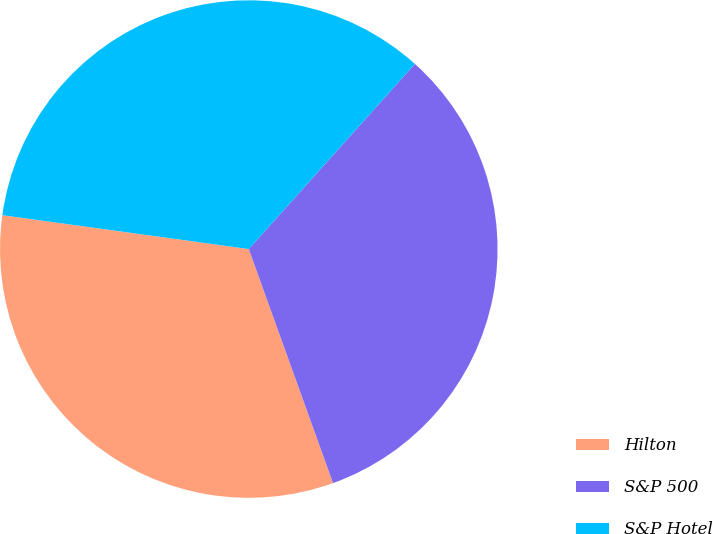Convert chart. <chart><loc_0><loc_0><loc_500><loc_500><pie_chart><fcel>Hilton<fcel>S&P 500<fcel>S&P Hotel<nl><fcel>32.67%<fcel>32.86%<fcel>34.46%<nl></chart> 